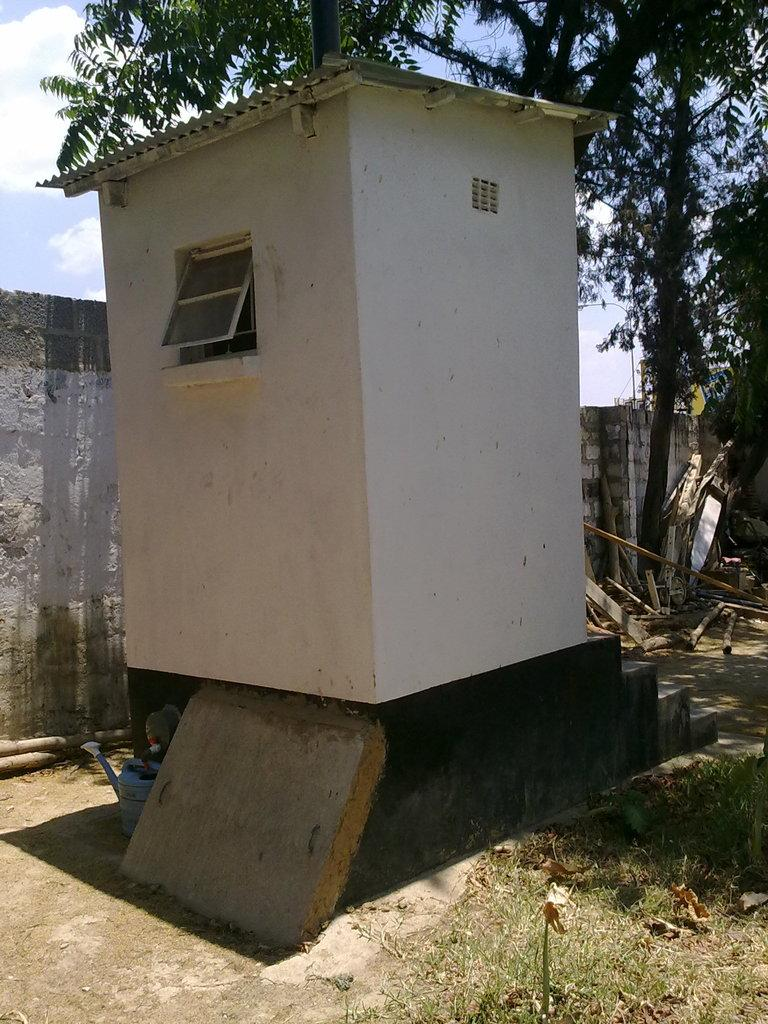What is located in the foreground of the image? There is a small house, a wall, stairs, wooden planks, and trees in the foreground of the image. Can you describe the elements in the foreground? The small house, wall, stairs, and wooden planks are man-made structures, while the trees are a natural element. What can be seen in the background of the image? The sky and clouds are visible in the background of the image. How many natural elements are present in the foreground? There is one natural element present in the foreground, which is the trees. What type of plant is causing the traffic jam in the image? There is no traffic jam or plant present in the image. How does the driving style of the person in the image affect the cause of the accident? There is no accident or person driving in the image. 